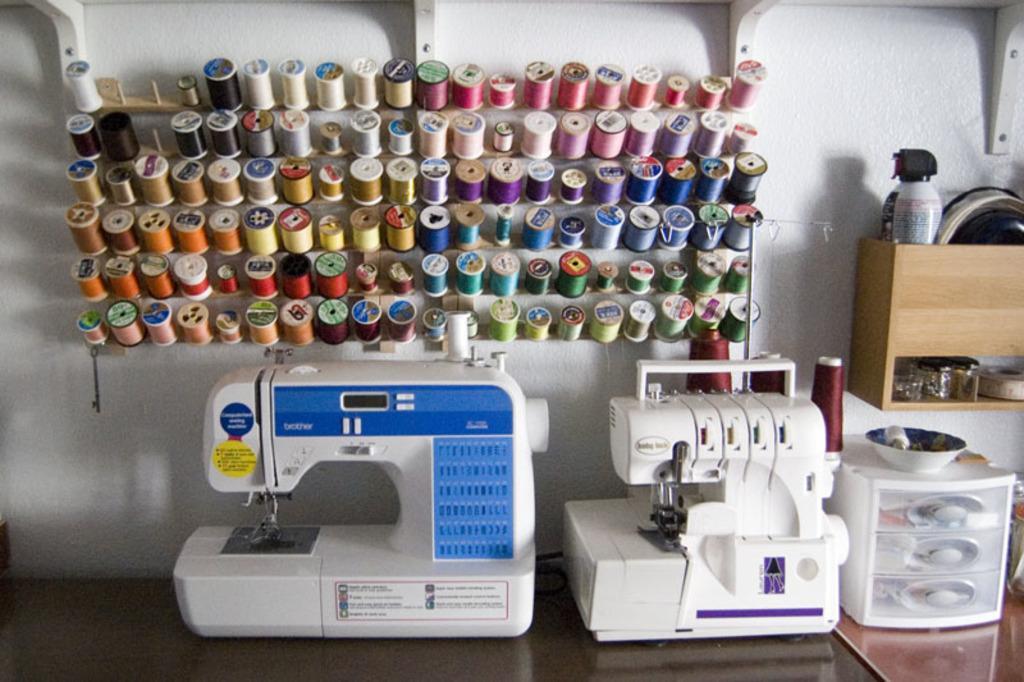Describe this image in one or two sentences. In this image, we can see sewing machines are placed on the surface. Top of the image, we can see a colorful thread bundles are on the hook. Background there is a wall. Right side of the image, we can see some objects, things, bowl. Here we can see some stands on the wall. 